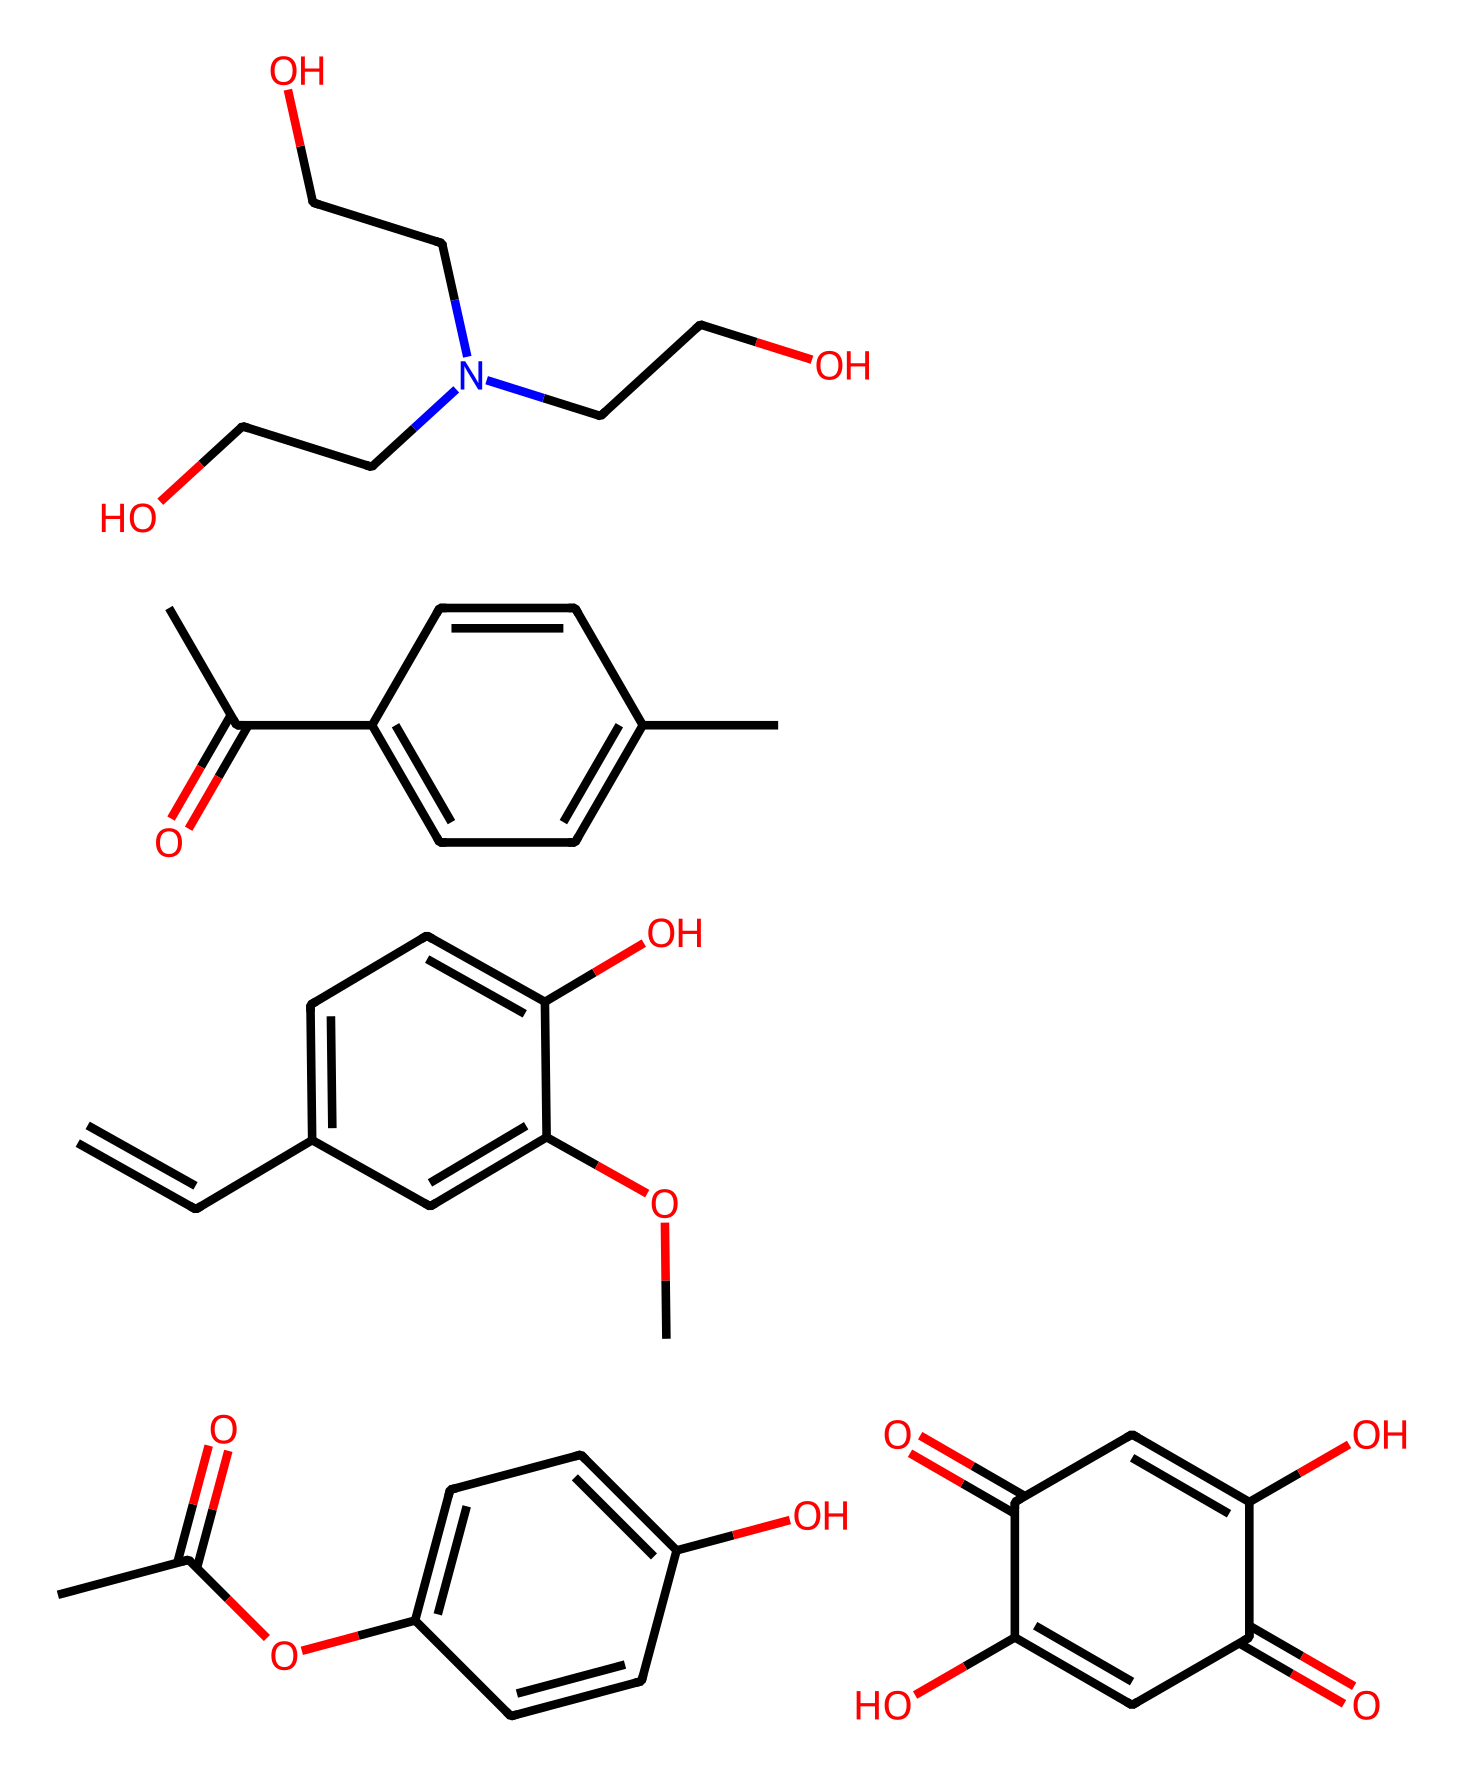What is the primary functional group present in the compound? The presence of the carbonyl group (C=O) indicates that the compound is a carboxylic acid since it is typically associated with acids.
Answer: carboxylic acid How many distinct rings are present in the chemical structure? By examining the SMILES notation, we can count each numbered ring. The presence of rings is indicated by the numbers, showing a total of five distinct rings in the compounds.
Answer: five What is the total number of hydroxyl (-OH) groups? Throughout the structure, each -OH group present can be counted. In this case, there are specific positions in the rings and other parts of the structures that indicate three distinct -OH groups.
Answer: three Which part of the chemical indicates a potential antioxidant property? The multiple hydroxyl (-OH) groups often present in phenolic compounds can indicate antioxidant properties, which can be deduced from their locations in the aromatic rings.
Answer: hydroxyl groups What is the molecular formula for the first part of the compound? By analyzing the first portion of the SMILES string, which corresponds to acetic acid and a benzene derivative, we can derive the molecular formula as C10H12O4.
Answer: C10H12O4 